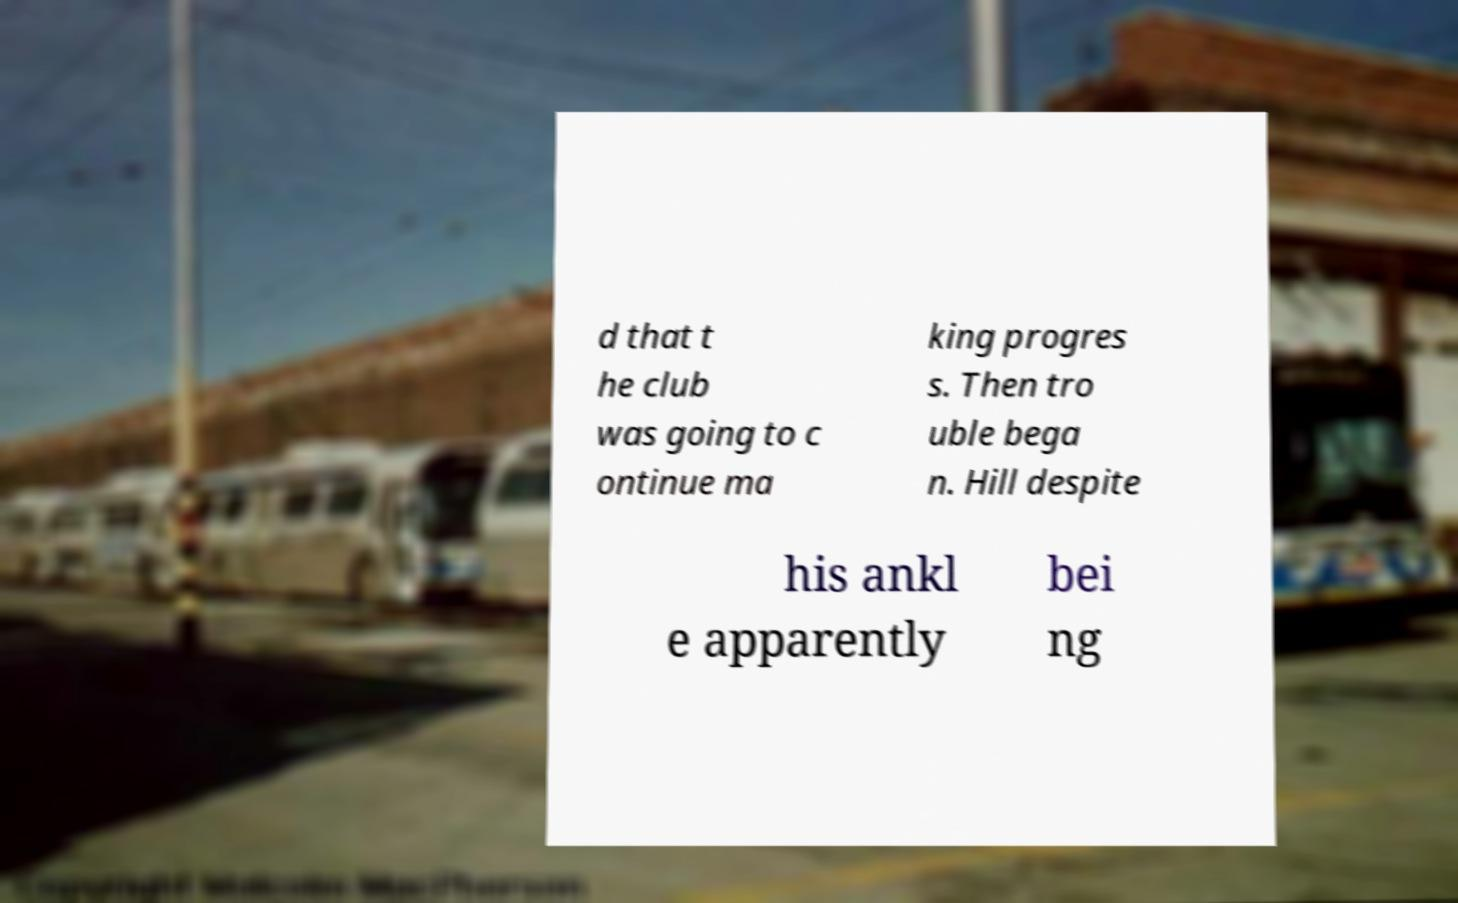Could you extract and type out the text from this image? d that t he club was going to c ontinue ma king progres s. Then tro uble bega n. Hill despite his ankl e apparently bei ng 